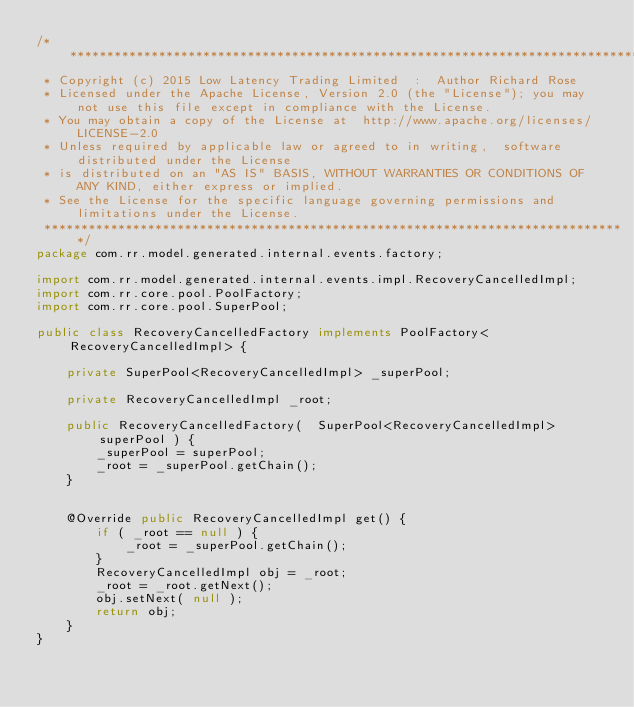Convert code to text. <code><loc_0><loc_0><loc_500><loc_500><_Java_>/*******************************************************************************
 * Copyright (c) 2015 Low Latency Trading Limited  :  Author Richard Rose
 * Licensed under the Apache License, Version 2.0 (the "License"); you may not use this file except in compliance with the License.
 * You may obtain a copy of the License at	http://www.apache.org/licenses/LICENSE-2.0
 * Unless required by applicable law or agreed to in writing,  software distributed under the License 
 * is distributed on an "AS IS" BASIS, WITHOUT WARRANTIES OR CONDITIONS OF ANY KIND, either express or implied.
 * See the License for the specific language governing permissions and limitations under the License.
 *******************************************************************************/
package com.rr.model.generated.internal.events.factory;

import com.rr.model.generated.internal.events.impl.RecoveryCancelledImpl;
import com.rr.core.pool.PoolFactory;
import com.rr.core.pool.SuperPool;

public class RecoveryCancelledFactory implements PoolFactory<RecoveryCancelledImpl> {

    private SuperPool<RecoveryCancelledImpl> _superPool;

    private RecoveryCancelledImpl _root;

    public RecoveryCancelledFactory(  SuperPool<RecoveryCancelledImpl> superPool ) {
        _superPool = superPool;
        _root = _superPool.getChain();
    }


    @Override public RecoveryCancelledImpl get() {
        if ( _root == null ) {
            _root = _superPool.getChain();
        }
        RecoveryCancelledImpl obj = _root;
        _root = _root.getNext();
        obj.setNext( null );
        return obj;
    }
}
</code> 